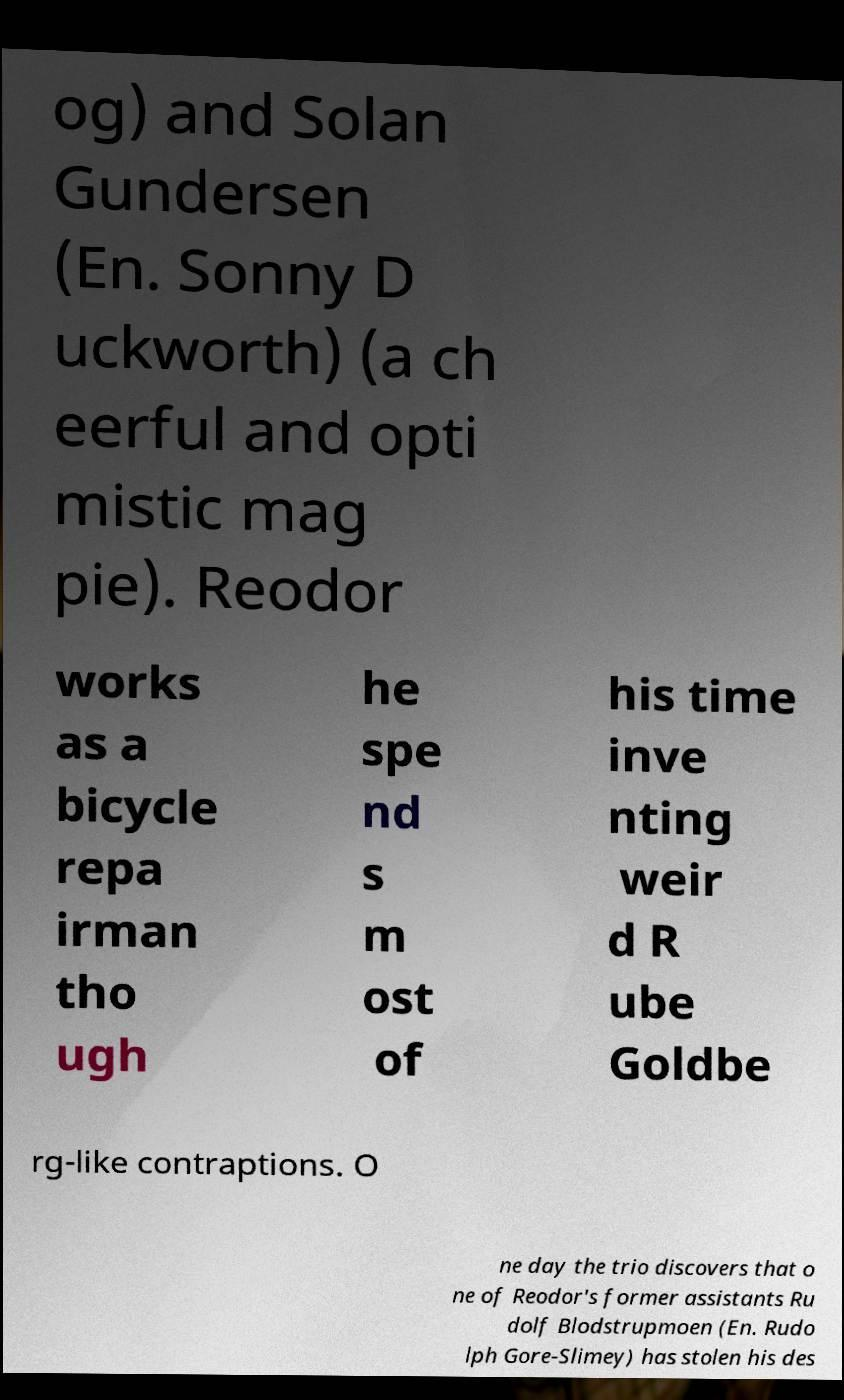What messages or text are displayed in this image? I need them in a readable, typed format. og) and Solan Gundersen (En. Sonny D uckworth) (a ch eerful and opti mistic mag pie). Reodor works as a bicycle repa irman tho ugh he spe nd s m ost of his time inve nting weir d R ube Goldbe rg-like contraptions. O ne day the trio discovers that o ne of Reodor's former assistants Ru dolf Blodstrupmoen (En. Rudo lph Gore-Slimey) has stolen his des 